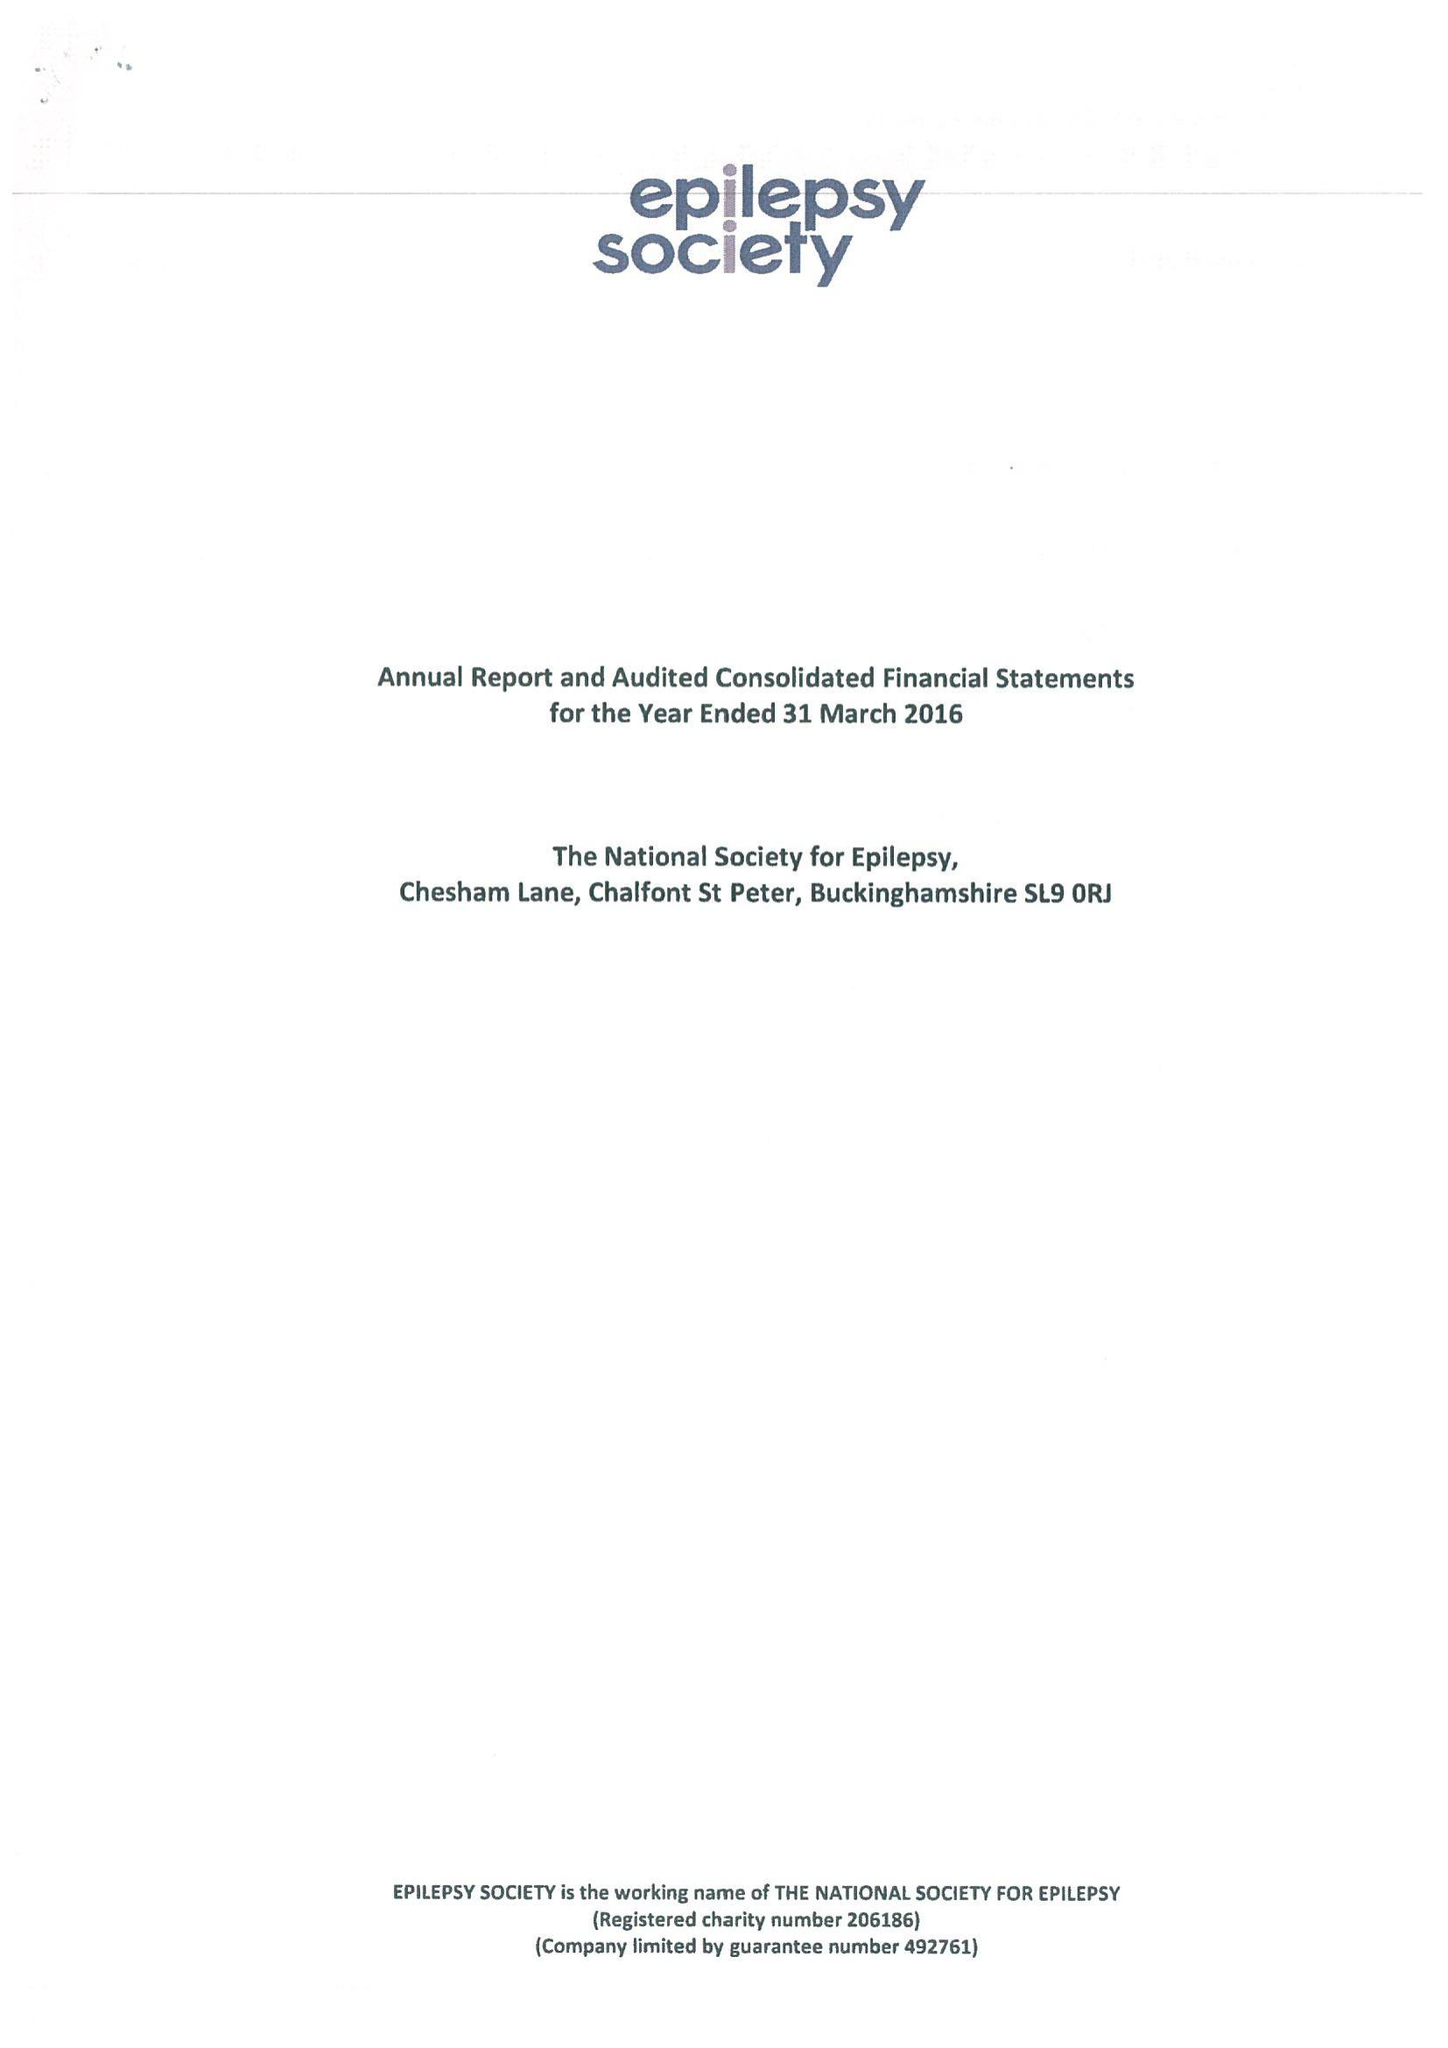What is the value for the address__postcode?
Answer the question using a single word or phrase. SL9 0RJ 